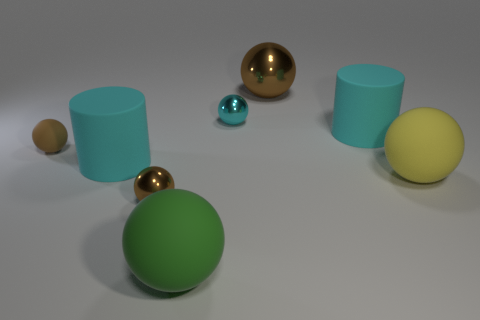What number of big cylinders are on the left side of the cyan cylinder right of the large metallic object?
Your response must be concise. 1. Is the tiny matte object the same color as the large metal thing?
Provide a succinct answer. Yes. How many other objects are there of the same material as the cyan ball?
Keep it short and to the point. 2. There is a brown thing that is in front of the cyan cylinder left of the large green object; what shape is it?
Ensure brevity in your answer.  Sphere. There is a matte ball in front of the large yellow rubber thing; how big is it?
Your response must be concise. Large. Is the yellow sphere made of the same material as the green object?
Give a very brief answer. Yes. What is the shape of the green thing that is the same material as the large yellow ball?
Ensure brevity in your answer.  Sphere. Is there anything else that has the same color as the large metal ball?
Your answer should be very brief. Yes. There is a big matte cylinder on the right side of the big metal thing; what color is it?
Provide a short and direct response. Cyan. There is a large ball in front of the big yellow thing; is its color the same as the tiny rubber ball?
Ensure brevity in your answer.  No. 